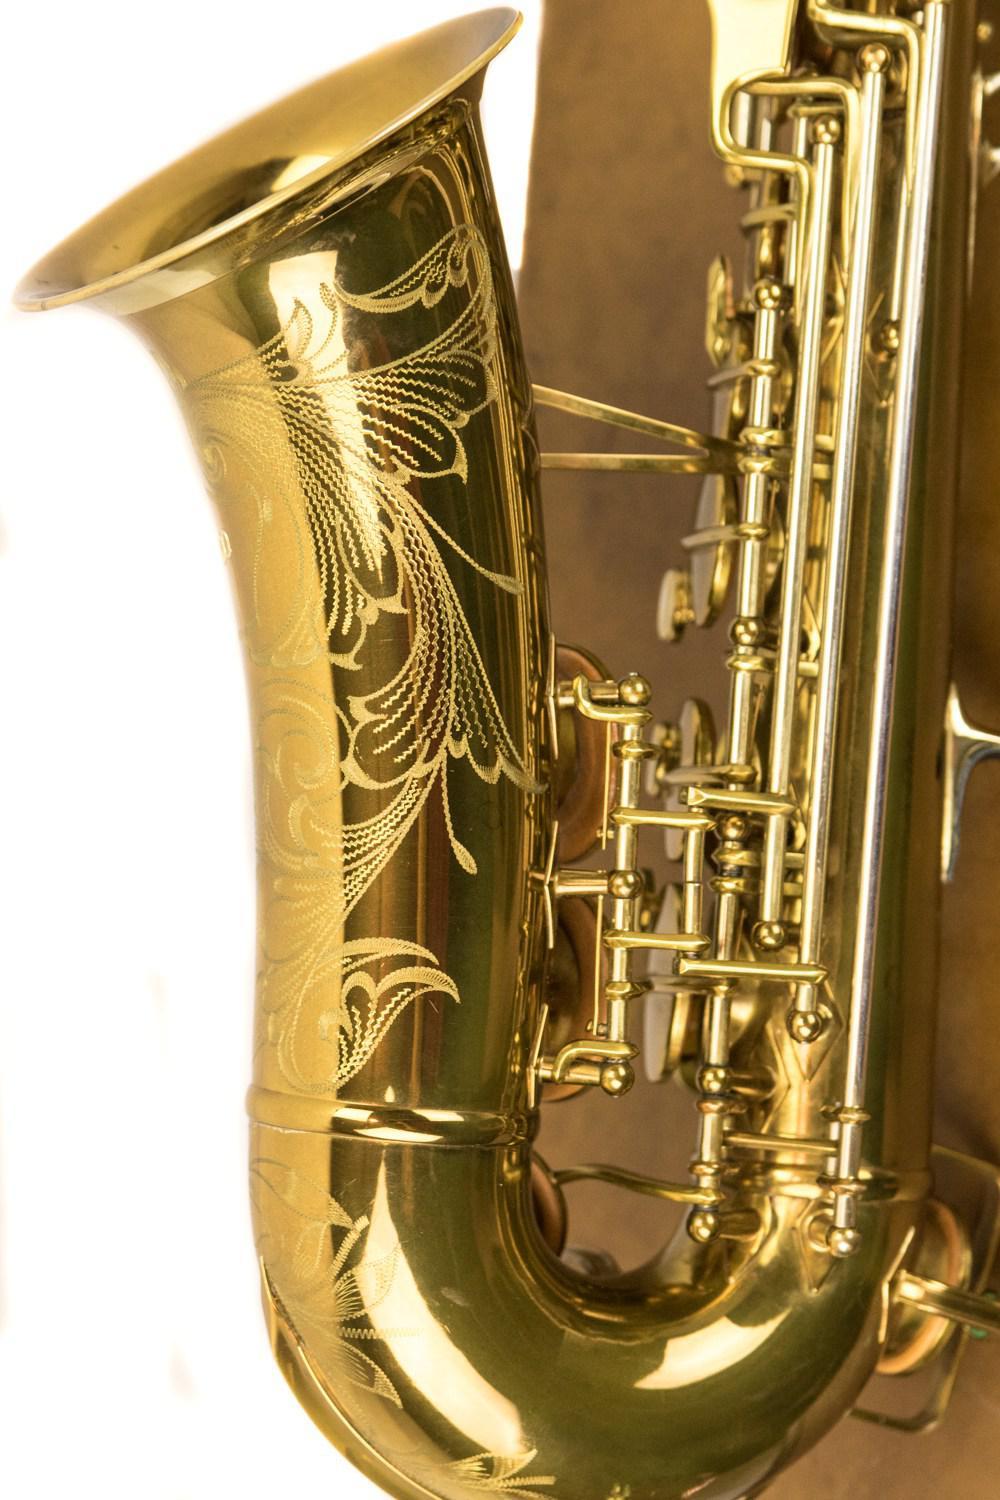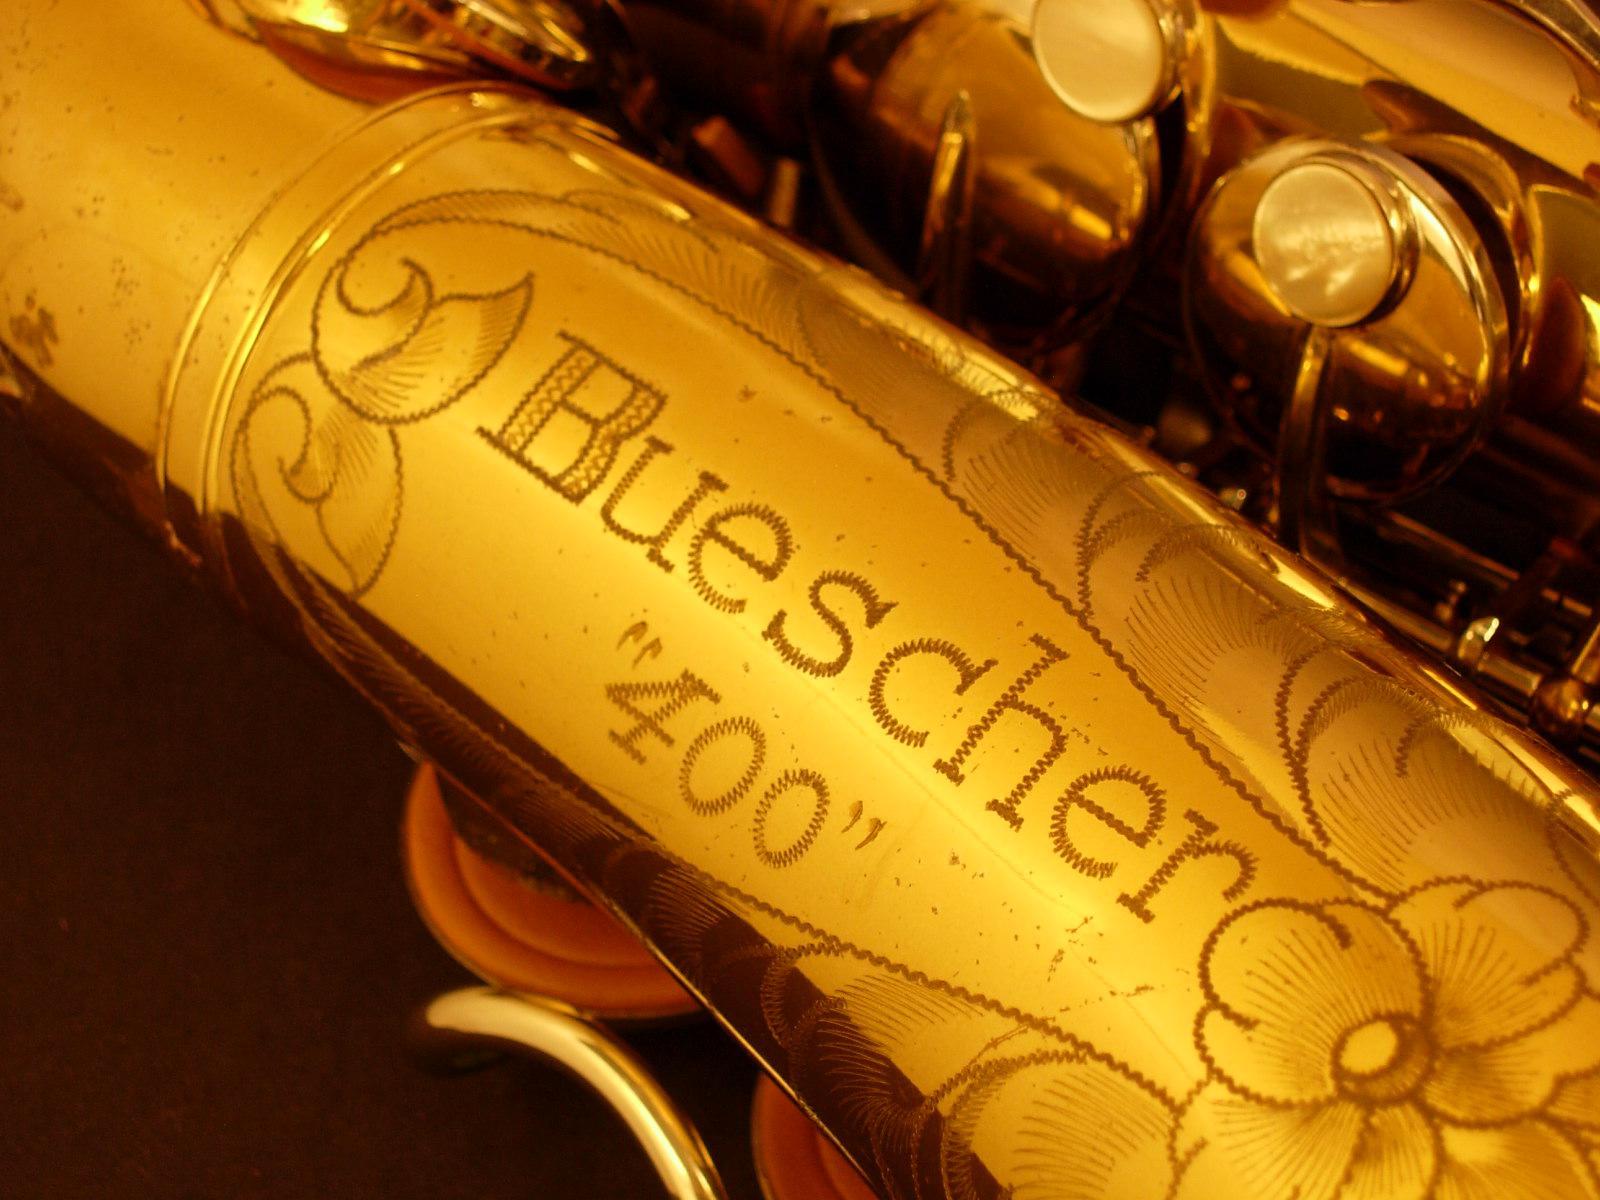The first image is the image on the left, the second image is the image on the right. Analyze the images presented: Is the assertion "One image shows the gold-colored bell of a saxophone turned leftward, and the other image shows decorative scrolled etching on a gold-colored instrument." valid? Answer yes or no. Yes. The first image is the image on the left, the second image is the image on the right. For the images displayed, is the sentence "A word and number are engraved on the saxophone in the image on the right." factually correct? Answer yes or no. Yes. 